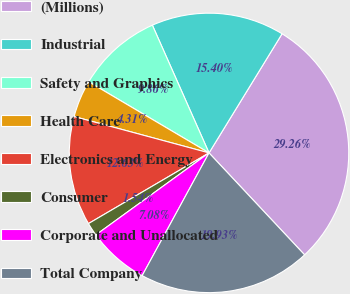Convert chart. <chart><loc_0><loc_0><loc_500><loc_500><pie_chart><fcel>(Millions)<fcel>Industrial<fcel>Safety and Graphics<fcel>Health Care<fcel>Electronics and Energy<fcel>Consumer<fcel>Corporate and Unallocated<fcel>Total Company<nl><fcel>29.26%<fcel>15.4%<fcel>9.86%<fcel>4.31%<fcel>12.63%<fcel>1.54%<fcel>7.08%<fcel>19.93%<nl></chart> 